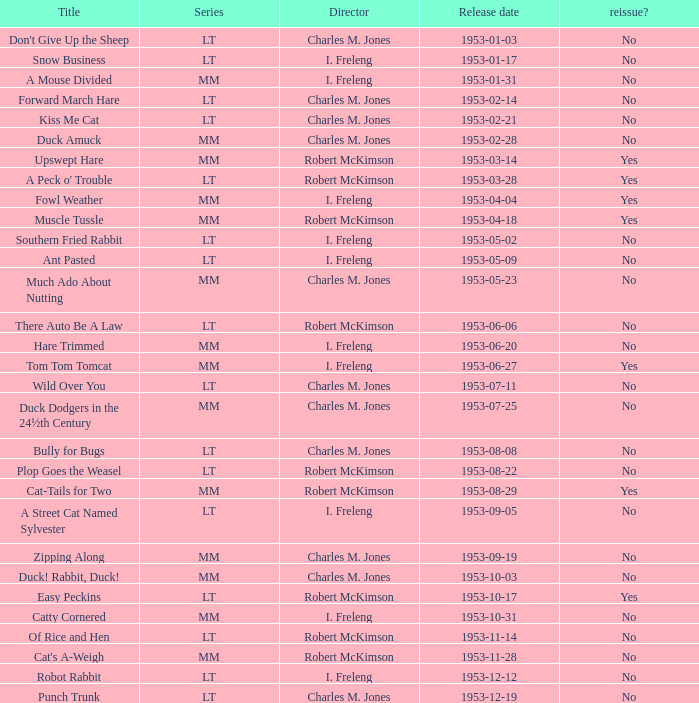What's the sequence of kiss me cat? LT. 